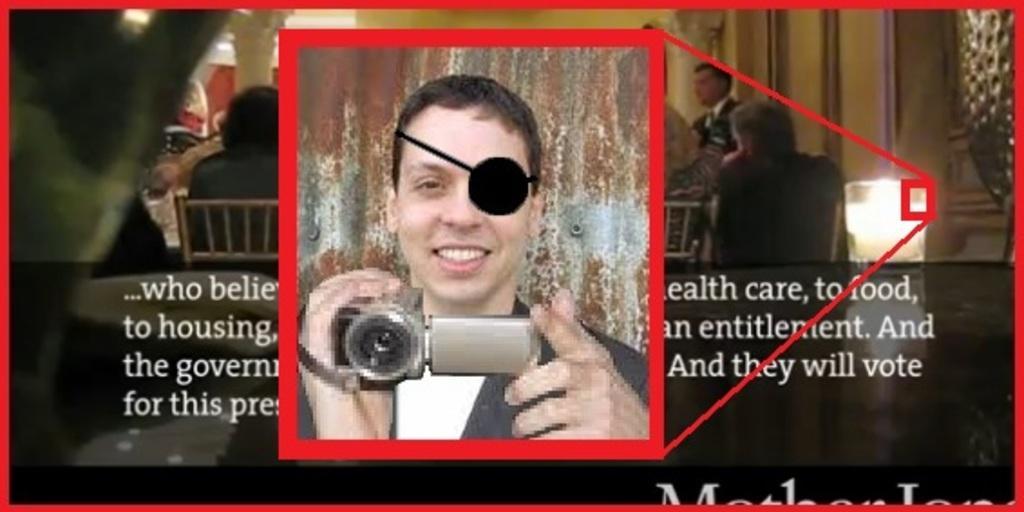Could you give a brief overview of what you see in this image? In the image there is a poster. On the poster there is an image of a man holding a camera in his hand. And also there are few people. And here is some text on the poster. 